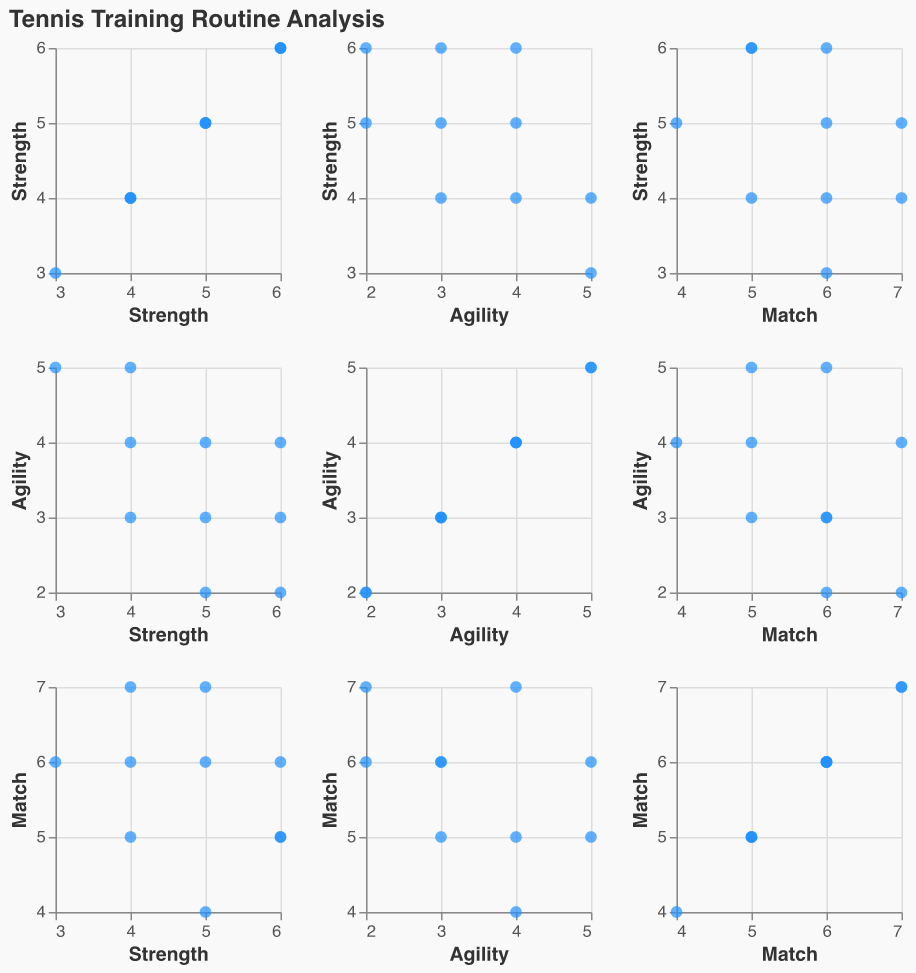What is the title of the scatter plot matrix? The title of the plot is usually placed at the top and it describes what is depicted in the figure. Here, it indicates the analysis being presented.
Answer: Tennis Training Routine Analysis How many data points are plotted in each panel of the scatter plot matrix? To determine the number of data points, count how many points are present in any of the panels. Each panel should have the same number of data points as they all represent the same data set.
Answer: 10 Which training type shows the highest variability in hours spent among the players? By observing the range of values along each axis, you can determine the variability. The training type with the widest spread of points has the highest variability.
Answer: Agility Training Is there a positive or negative correlation between hours spent on Strength Training and Match Practice? To determine the correlation, observe whether the data points show an upward trend (positive correlation) or a downward trend (negative correlation) as you move along the axes.
Answer: Negative correlation What is the average number of hours spent on Agility Training? To find the average, sum all the hours spent on Agility Training and divide by the number of data points (10). The data points for Agility Training are: 3, 4, 3, 5, 4, 2, 5, 2, 3, 4. Summing these gives 35, and dividing by 10 results in an average of 3.5 hours.
Answer: 3.5 hours Who spends more hours on Match Practice, the player who spends 4 hours on Strength Training and 4 hours on Agility Training or the player who spends 6 hours on Strength Training and 3 hours on Agility Training? Look at the data points that match the given strength and agility hours. Compare the match practice hours for both. The first player has 7 hours and the second has 5.
Answer: 4 hours Strength & 4 hours Agility Is there any player who spends equal hours on Strength Training and Match Practice? Look for any data points where the hours on Strength Training and Match Practice are the same. None of the data points have the same values for these two variables.
Answer: No Which pair of training types has the weakest correlation based on the scatter plot matrix? Identify which pairs of training types show the least visible trend or have data points most scattered around the plot.
Answer: Strength Training and Agility Training On average, do players spend more time on Match Practice or Strength Training? Calculate the average hours for both Match Practice (sum is 57) and Strength Training (sum is 48), and compare. The average for Match Practice is 57/10 = 5.7 hours, for Strength Training it's 48/10 = 4.8 hours.
Answer: Match Practice 